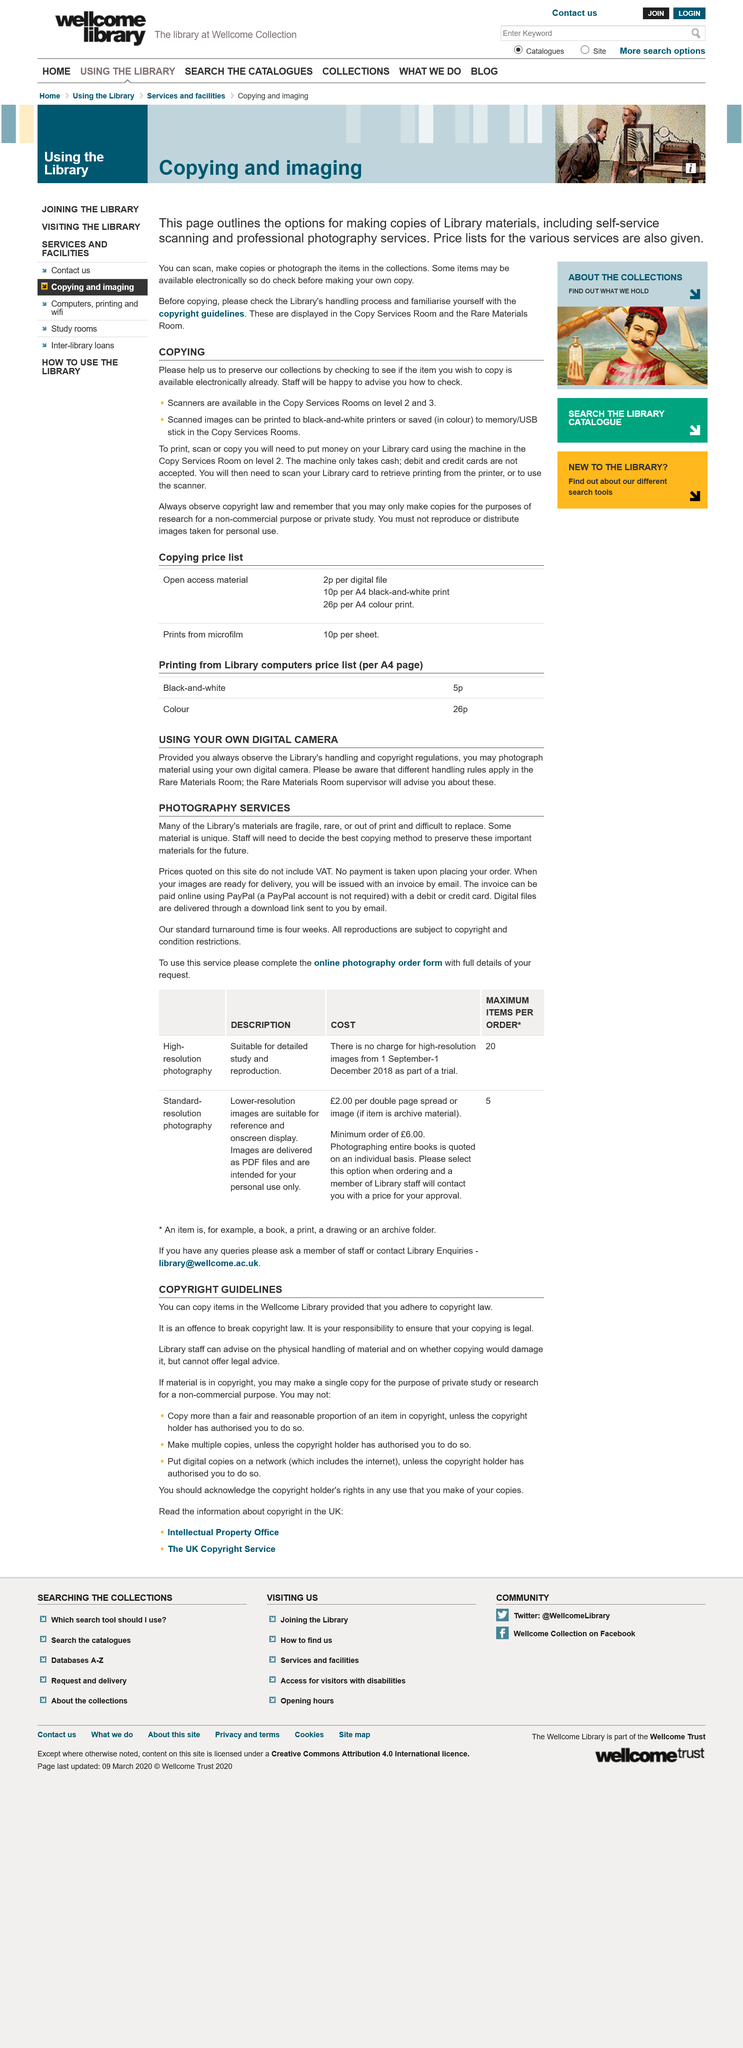Specify some key components in this picture. It is necessary for staff to determine the most suitable copying method in order to preserve valuable materials for future generations. Scanning in black and white is free to use, but printing requires a fee. To use a printer or scanner, two items are required: cash and a library card. If the material is in copyright, one copy can be made for the purpose of private study or research for a non-commercial purpose. A person on level 3 will need to descend one floor to put money on a library card. 